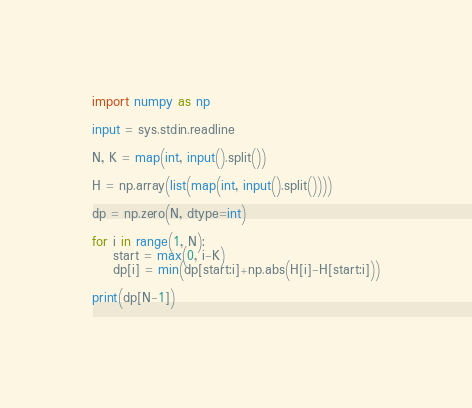<code> <loc_0><loc_0><loc_500><loc_500><_Python_>import numpy as np

input = sys.stdin.readline

N, K = map(int, input().split())

H = np.array(list(map(int, input().split())))

dp = np.zero(N, dtype=int)

for i in range(1, N):
    start = max(0, i-K)
    dp[i] = min(dp[start:i]+np.abs(H[i]-H[start:i]))

print(dp[N-1])
    </code> 